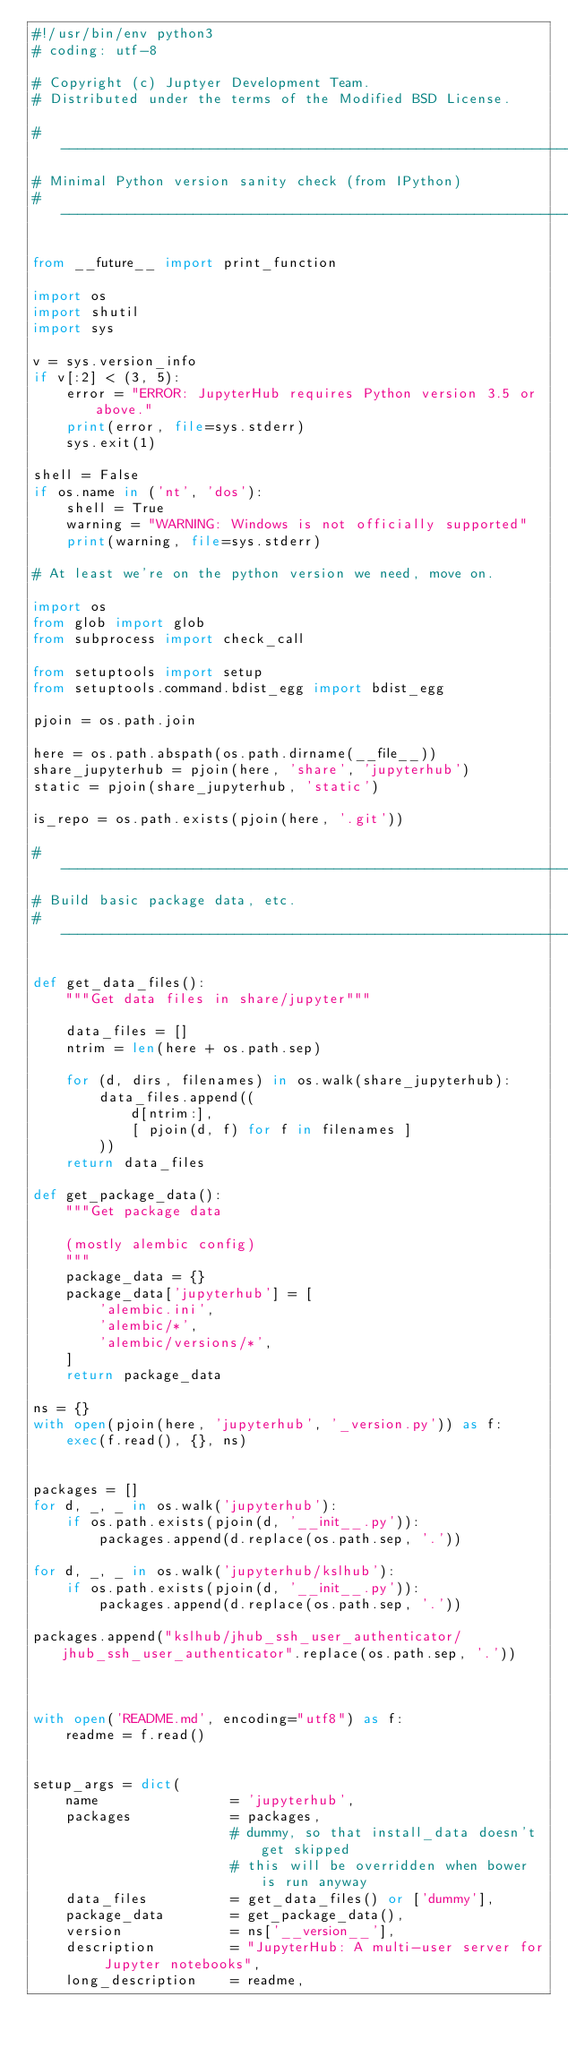Convert code to text. <code><loc_0><loc_0><loc_500><loc_500><_Python_>#!/usr/bin/env python3
# coding: utf-8

# Copyright (c) Juptyer Development Team.
# Distributed under the terms of the Modified BSD License.

#-----------------------------------------------------------------------------
# Minimal Python version sanity check (from IPython)
#-----------------------------------------------------------------------------

from __future__ import print_function

import os
import shutil
import sys

v = sys.version_info
if v[:2] < (3, 5):
    error = "ERROR: JupyterHub requires Python version 3.5 or above."
    print(error, file=sys.stderr)
    sys.exit(1)

shell = False
if os.name in ('nt', 'dos'):
    shell = True
    warning = "WARNING: Windows is not officially supported"
    print(warning, file=sys.stderr)

# At least we're on the python version we need, move on.

import os
from glob import glob
from subprocess import check_call

from setuptools import setup
from setuptools.command.bdist_egg import bdist_egg

pjoin = os.path.join

here = os.path.abspath(os.path.dirname(__file__))
share_jupyterhub = pjoin(here, 'share', 'jupyterhub')
static = pjoin(share_jupyterhub, 'static')

is_repo = os.path.exists(pjoin(here, '.git'))

#---------------------------------------------------------------------------
# Build basic package data, etc.
#---------------------------------------------------------------------------

def get_data_files():
    """Get data files in share/jupyter"""

    data_files = []
    ntrim = len(here + os.path.sep)

    for (d, dirs, filenames) in os.walk(share_jupyterhub):
        data_files.append((
            d[ntrim:],
            [ pjoin(d, f) for f in filenames ]
        ))
    return data_files

def get_package_data():
    """Get package data

    (mostly alembic config)
    """
    package_data = {}
    package_data['jupyterhub'] = [
        'alembic.ini',
        'alembic/*',
        'alembic/versions/*',
    ]
    return package_data

ns = {}
with open(pjoin(here, 'jupyterhub', '_version.py')) as f:
    exec(f.read(), {}, ns)


packages = []
for d, _, _ in os.walk('jupyterhub'):
    if os.path.exists(pjoin(d, '__init__.py')):
        packages.append(d.replace(os.path.sep, '.'))

for d, _, _ in os.walk('jupyterhub/kslhub'):
    if os.path.exists(pjoin(d, '__init__.py')):
        packages.append(d.replace(os.path.sep, '.'))

packages.append("kslhub/jhub_ssh_user_authenticator/jhub_ssh_user_authenticator".replace(os.path.sep, '.'))
        


with open('README.md', encoding="utf8") as f:
    readme = f.read()


setup_args = dict(
    name                = 'jupyterhub',
    packages            = packages,
                        # dummy, so that install_data doesn't get skipped
                        # this will be overridden when bower is run anyway
    data_files          = get_data_files() or ['dummy'],
    package_data        = get_package_data(),
    version             = ns['__version__'],
    description         = "JupyterHub: A multi-user server for Jupyter notebooks",
    long_description    = readme,</code> 